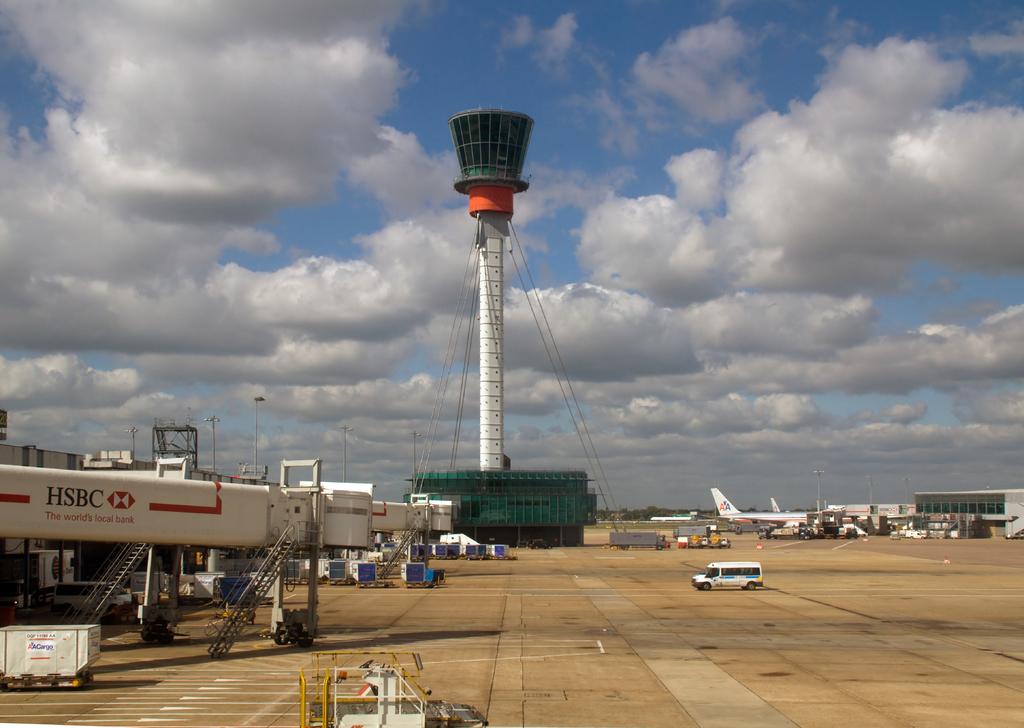What bank's logo is on the jet bridge?
Ensure brevity in your answer.  Hsbc. What is the company on the plane?
Make the answer very short. Aa. 